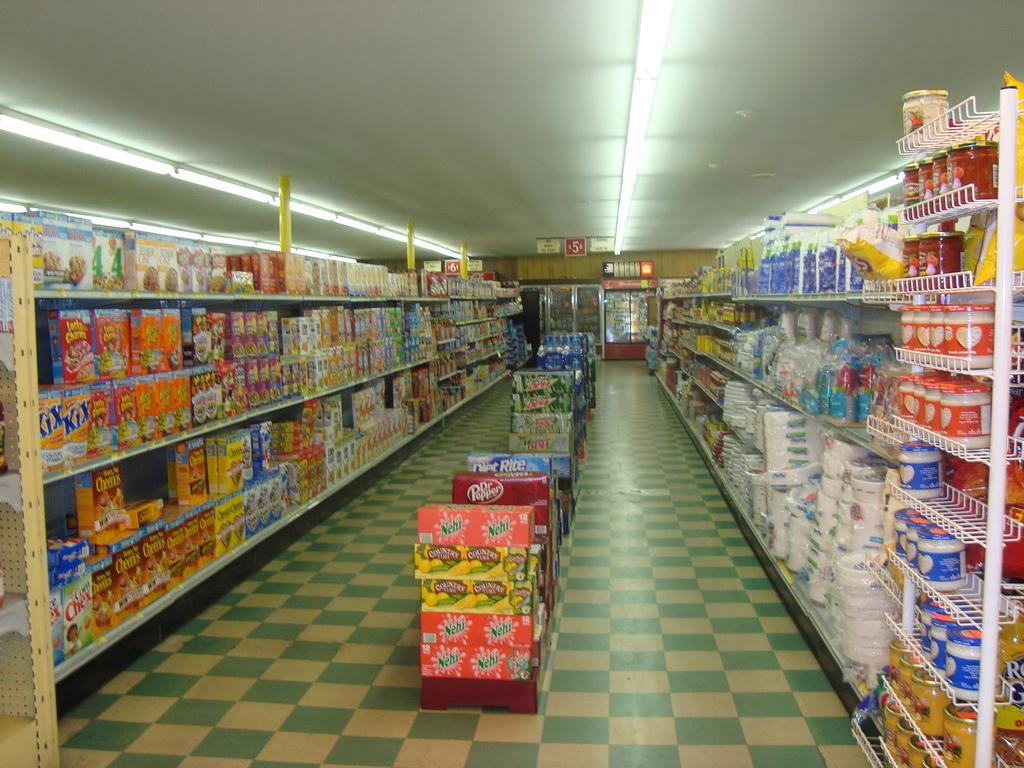<image>
Write a terse but informative summary of the picture. Nehi logo on a twelve pack of peach soda and a box of Kix. 